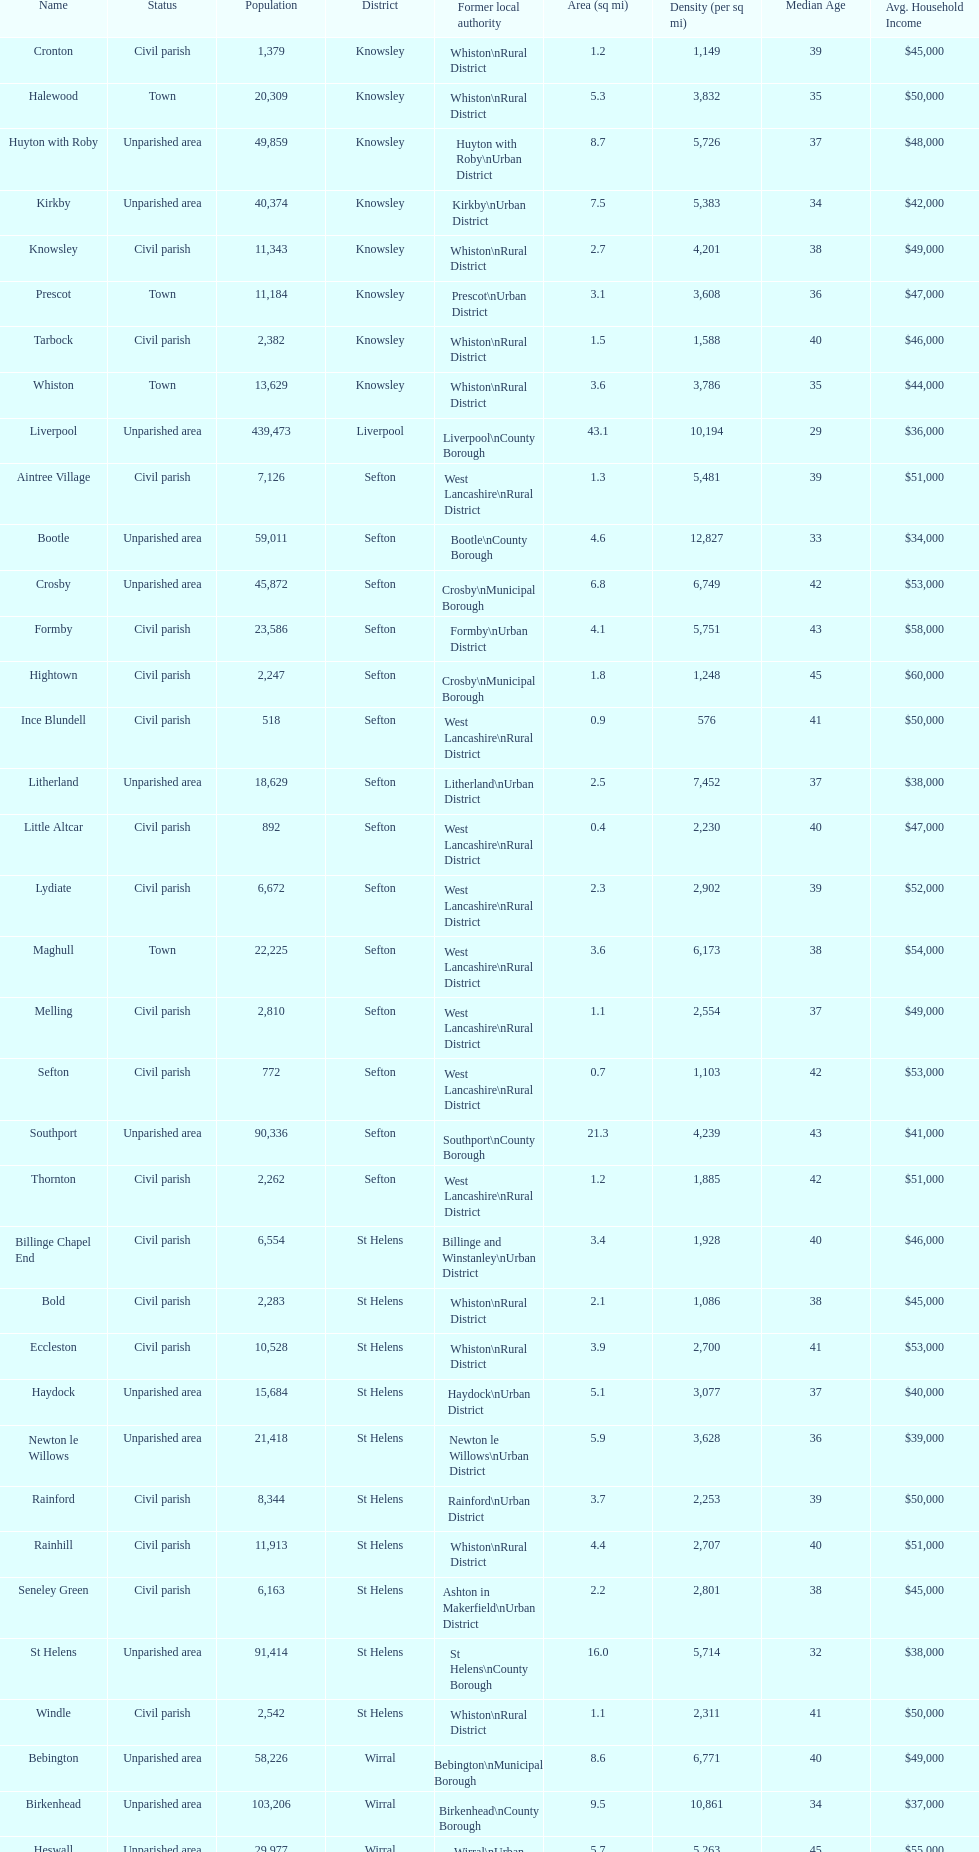How many people live in the bold civil parish? 2,283. 